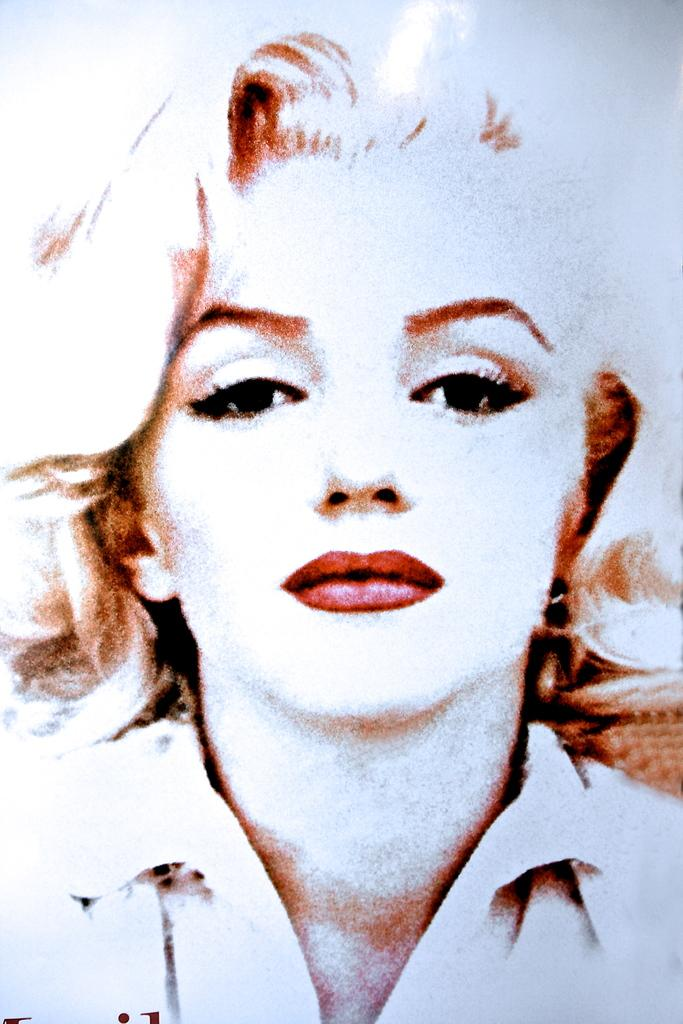What is the main subject of the image? The main subject of the image is a picture of a lady's face. How many legs can be seen in the image? There are no legs visible in the image, as it features a picture of a lady's face. Is there a lock on the lady's face in the image? No, there is no lock present in the image; it features a picture of a lady's face. 